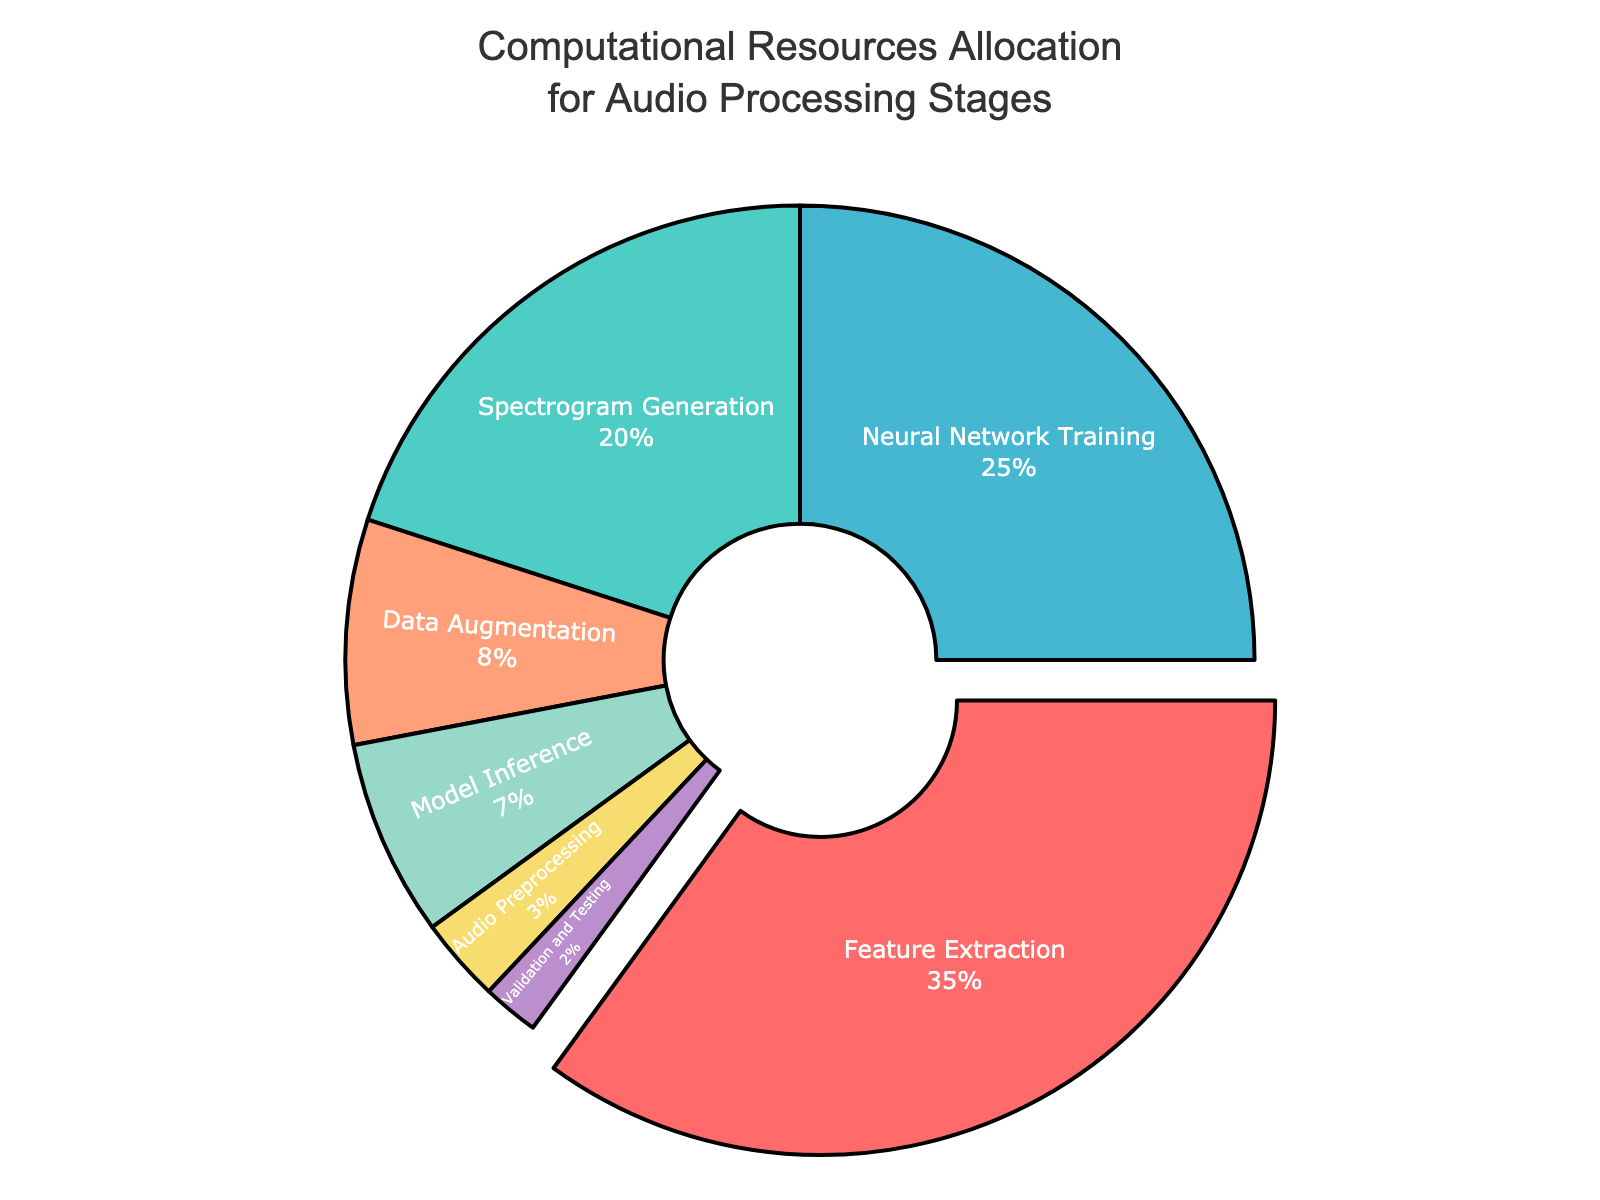What is the largest allocation of computational resources? The largest allocation can be determined by looking for the largest percentage value in the pie chart. "Feature Extraction" has the largest segment, comprising 35% of the total resources.
Answer: Feature Extraction What is the combined percentage of resources allocated to Neural Network Training and Spectrogram Generation? To find the combined allocation, add the percentages of "Neural Network Training" (25%) and "Spectrogram Generation" (20%). So, 25% + 20% = 45%.
Answer: 45% Which stage has the smallest allocation of resources, and what is its percentage? The smallest allocation is represented by the smallest segment in the pie chart. "Validation and Testing" has the smallest segment, with an allocation of 2%.
Answer: Validation and Testing, 2% Does Audio Preprocessing have a higher, lower, or equal allocation compared to Model Inference? Compare the percentages of "Audio Preprocessing" (3%) and "Model Inference" (7%). Since 3% < 7%, "Audio Preprocessing" has a lower allocation.
Answer: Lower What is the total percentage of resources allocated to stages other than Feature Extraction? Subtract the percentage of "Feature Extraction" from 100% to find the remaining allocation. So, 100% - 35% = 65%.
Answer: 65% If the resources for Neural Network Training were increased by 10%, what would the new allocation percentage be? Increase the "Neural Network Training" percentage by 10%. So, 25% + 10% = 35%.
Answer: 35% Which stages have allocations greater than 20%? Identify stages with percentages greater than 20%. "Feature Extraction" (35%) and "Neural Network Training" (25%) both have allocations greater than 20%.
Answer: Feature Extraction, Neural Network Training What is the ratio of resources allocated to Spectrogram Generation compared to Data Augmentation? Divide the percentage of "Spectrogram Generation" (20%) by "Data Augmentation" (8%). So, the ratio is 20 to 8, simplified as 5:2.
Answer: 5:2 If Data Augmentation and Audio Preprocessing percentages were combined, would their total exceed Spectrogram Generation? Add the percentages of "Data Augmentation" (8%) and "Audio Preprocessing" (3%). So, 8% + 3% = 11%. Compare 11% with "Spectrogram Generation" (20%). Since 11% < 20%, their combined total does not exceed Spectrogram Generation.
Answer: No Which segment is represented by a green color, and what is its percentage allocation? Visual inspection of the pie chart shows that the green segment corresponds to "Spectrogram Generation," with a percentage allocation of 20%.
Answer: Spectrogram Generation, 20% 